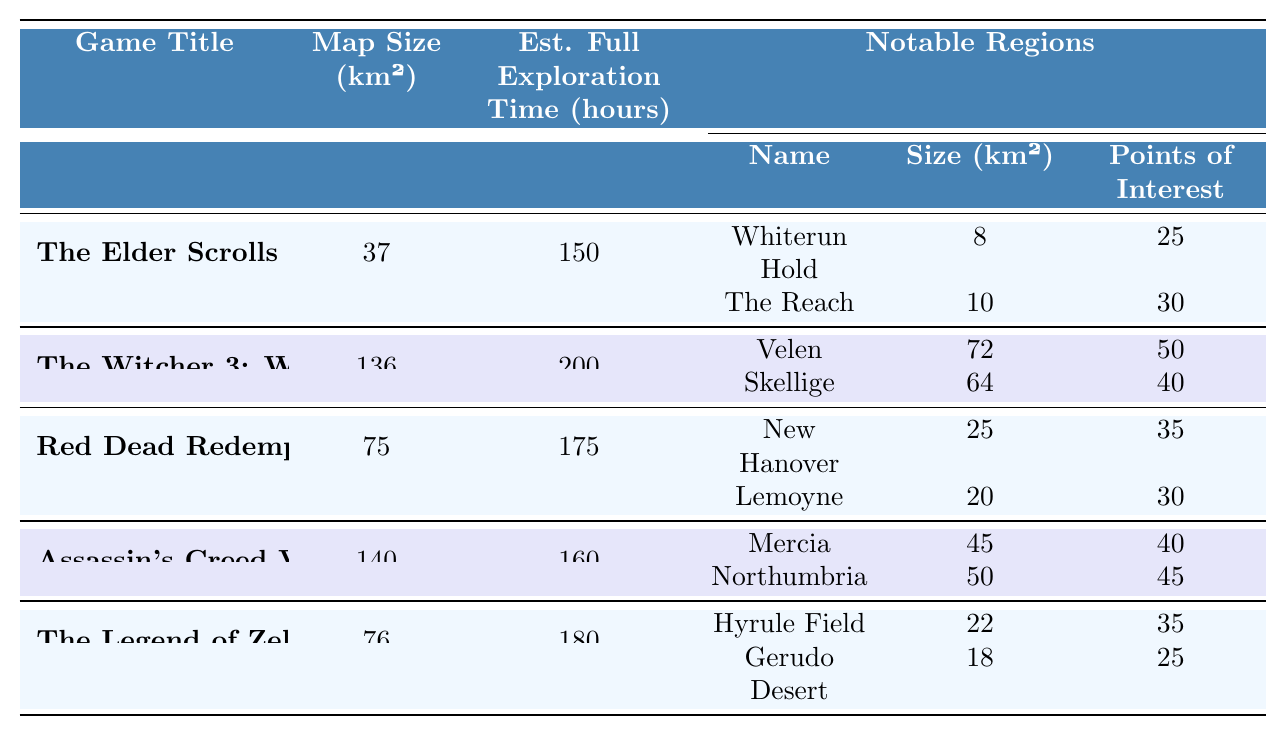What is the map size of The Witcher 3: Wild Hunt? The table lists the map size of The Witcher 3: Wild Hunt in the second row of the column for map size. It shows 136 km².
Answer: 136 km² Which game has the largest estimated full exploration time? By examining the estimated full exploration time in the table, The Witcher 3: Wild Hunt has the highest value at 200 hours.
Answer: The Witcher 3: Wild Hunt How many points of interest are in Velen? The table specifies that Velen, a notable region in The Witcher 3: Wild Hunt, has 50 points of interest listed under the points of interest column.
Answer: 50 Which game has a map size closest to 80 km²? Looking at the map sizes, The Legend of Zelda: Breath of the Wild has a map size of 76 km², which is closest to 80 km² compared to the other games listed.
Answer: The Legend of Zelda: Breath of the Wild What is the total size of the notable regions in Red Dead Redemption 2? The notable regions New Hanover (25 km²) and Lemoyne (20 km²) can be summed to find the total size: 25 + 20 = 45 km².
Answer: 45 km² Is the map size of Assassin's Creed Valhalla larger than that of Red Dead Redemption 2? As per the table, Assassin's Creed Valhalla has a map size of 140 km², while Red Dead Redemption 2 has 75 km², indicating that Valhalla's map size is indeed larger.
Answer: Yes What is the average estimated full exploration time of all the games listed? The estimated full exploration times are 150, 200, 175, 160, and 180 hours. The total is 150 + 200 + 175 + 160 + 180 = 865 hours. Dividing by 5 (the number of games) gives an average of 865 / 5 = 173 hours.
Answer: 173 hours Which game has notable regions with the most points of interest in total? To find out, we calculate the total points of interest for each game: The Witcher 3: Wild Hunt has 50 + 40 = 90, Skyrim has 25 + 30 = 55, Red Dead Redemption 2 has 35 + 30 = 65, Assassin's Creed Valhalla has 40 + 45 = 85, and The Legend of Zelda has 35 + 25 = 60. The game with the highest points of interest is The Witcher 3: Wild Hunt with 90 points.
Answer: The Witcher 3: Wild Hunt What is the difference in map size between The Elder Scrolls V: Skyrim and Assassin's Creed Valhalla? The map size of Skyrim is 37 km² while Valhalla's map size is 140 km². The difference is calculated as 140 - 37 = 103 km².
Answer: 103 km² 